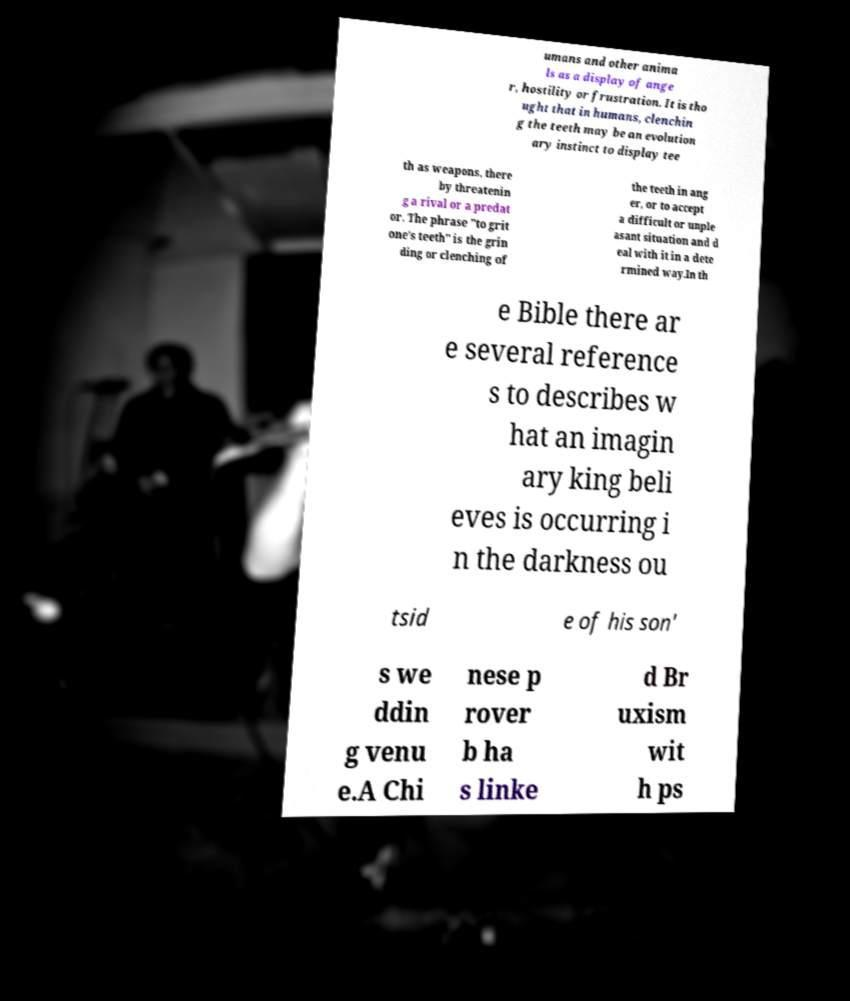Please identify and transcribe the text found in this image. umans and other anima ls as a display of ange r, hostility or frustration. It is tho ught that in humans, clenchin g the teeth may be an evolution ary instinct to display tee th as weapons, there by threatenin g a rival or a predat or. The phrase "to grit one's teeth" is the grin ding or clenching of the teeth in ang er, or to accept a difficult or unple asant situation and d eal with it in a dete rmined way.In th e Bible there ar e several reference s to describes w hat an imagin ary king beli eves is occurring i n the darkness ou tsid e of his son' s we ddin g venu e.A Chi nese p rover b ha s linke d Br uxism wit h ps 